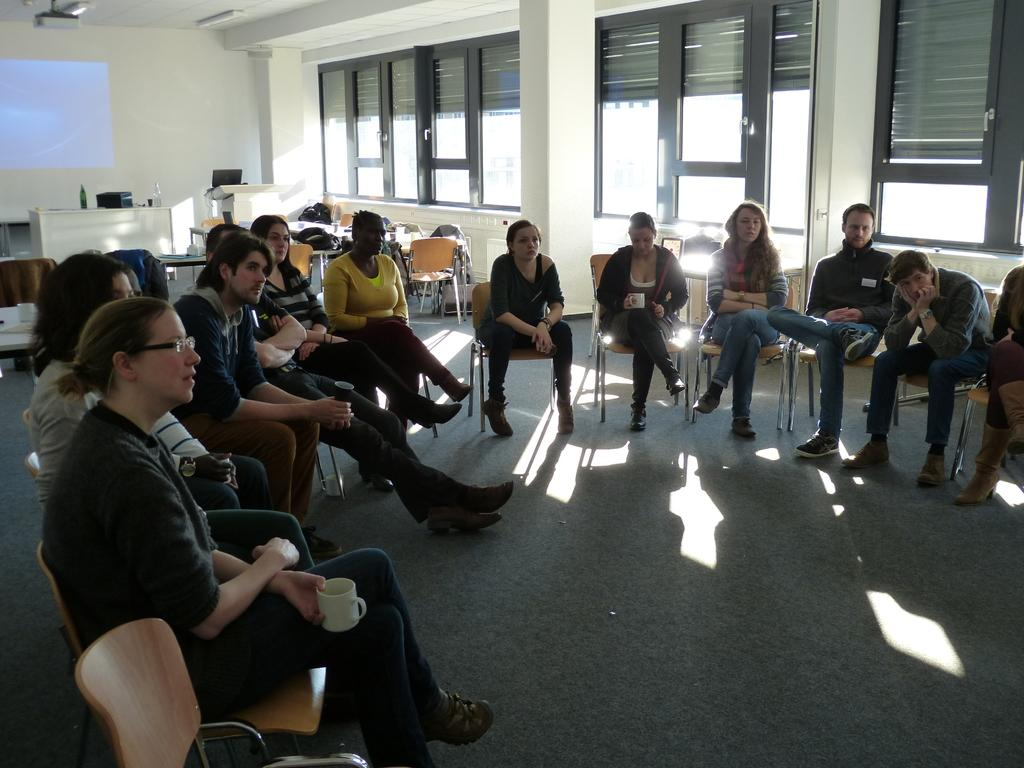What are the people in the image doing? The people in the image are sitting on chairs. What can be seen in the background of the image? There are several glass windows in the background of the image. What type of window treatment is present in the background? There are curtains on top of the glass windows in the background. What type of protest is taking place outside the window in the image? There is no protest visible in the image; it only shows people sitting on chairs and glass windows with curtains in the background. 